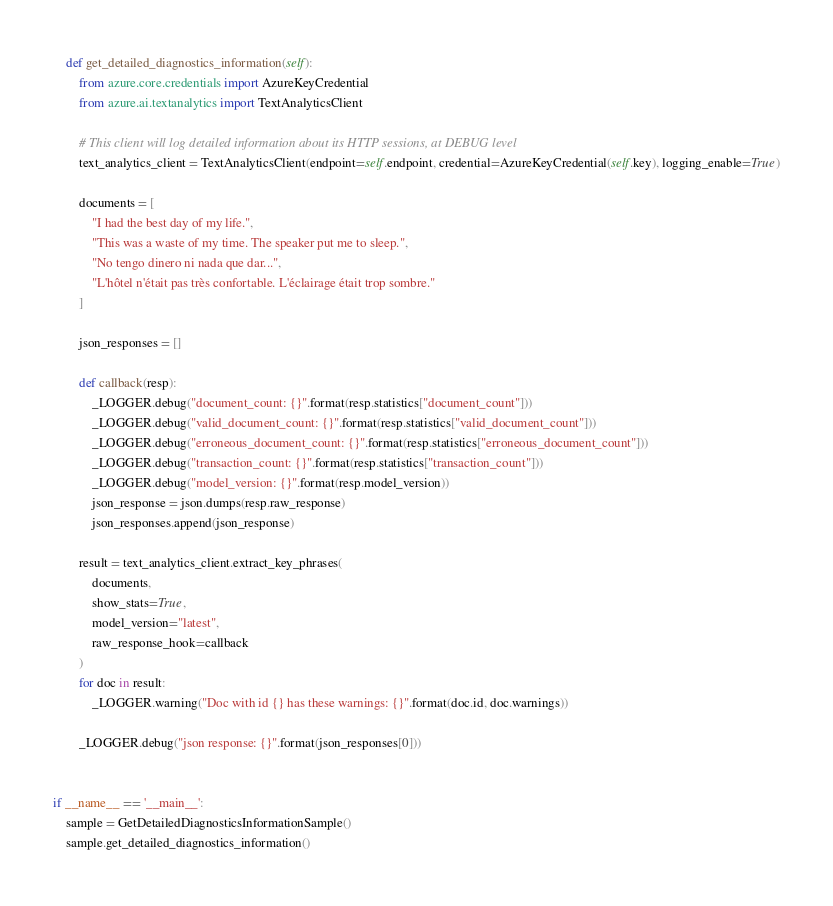Convert code to text. <code><loc_0><loc_0><loc_500><loc_500><_Python_>
    def get_detailed_diagnostics_information(self):
        from azure.core.credentials import AzureKeyCredential
        from azure.ai.textanalytics import TextAnalyticsClient

        # This client will log detailed information about its HTTP sessions, at DEBUG level
        text_analytics_client = TextAnalyticsClient(endpoint=self.endpoint, credential=AzureKeyCredential(self.key), logging_enable=True)

        documents = [
            "I had the best day of my life.",
            "This was a waste of my time. The speaker put me to sleep.",
            "No tengo dinero ni nada que dar...",
            "L'hôtel n'était pas très confortable. L'éclairage était trop sombre."
        ]

        json_responses = []

        def callback(resp):
            _LOGGER.debug("document_count: {}".format(resp.statistics["document_count"]))
            _LOGGER.debug("valid_document_count: {}".format(resp.statistics["valid_document_count"]))
            _LOGGER.debug("erroneous_document_count: {}".format(resp.statistics["erroneous_document_count"]))
            _LOGGER.debug("transaction_count: {}".format(resp.statistics["transaction_count"]))
            _LOGGER.debug("model_version: {}".format(resp.model_version))
            json_response = json.dumps(resp.raw_response)
            json_responses.append(json_response)

        result = text_analytics_client.extract_key_phrases(
            documents,
            show_stats=True,
            model_version="latest",
            raw_response_hook=callback
        )
        for doc in result:
            _LOGGER.warning("Doc with id {} has these warnings: {}".format(doc.id, doc.warnings))

        _LOGGER.debug("json response: {}".format(json_responses[0]))


if __name__ == '__main__':
    sample = GetDetailedDiagnosticsInformationSample()
    sample.get_detailed_diagnostics_information()
</code> 